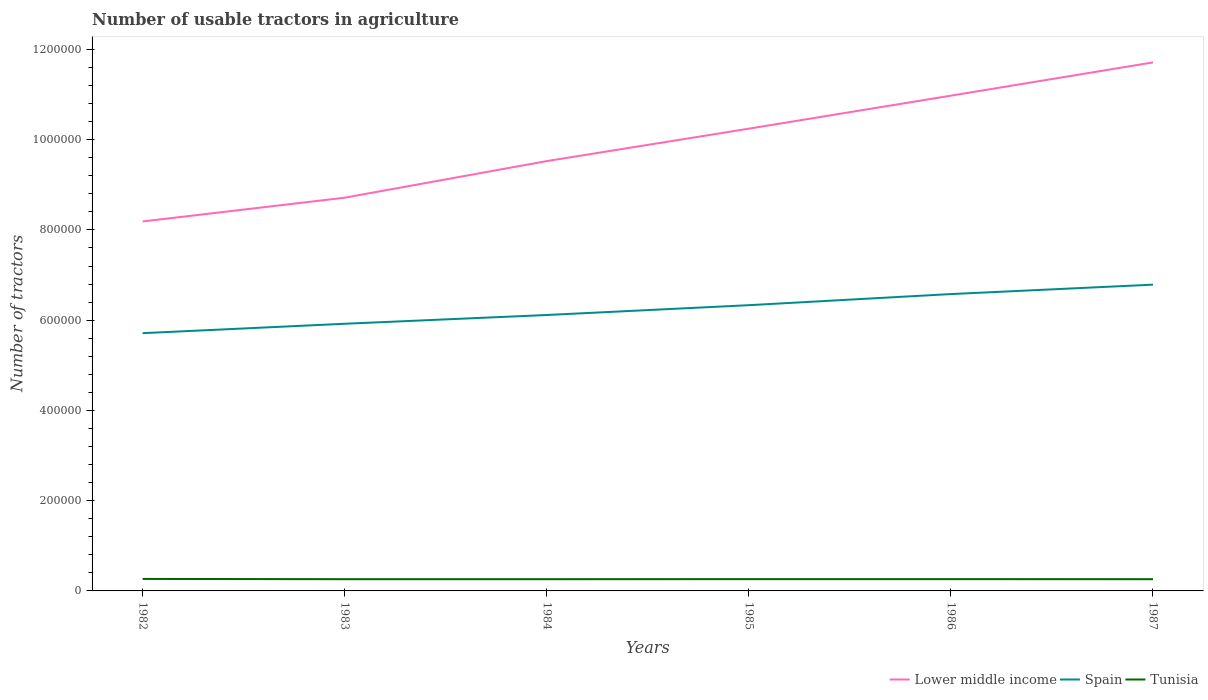Across all years, what is the maximum number of usable tractors in agriculture in Lower middle income?
Give a very brief answer. 8.19e+05. In which year was the number of usable tractors in agriculture in Lower middle income maximum?
Your answer should be very brief. 1982. What is the total number of usable tractors in agriculture in Spain in the graph?
Provide a succinct answer. -2.09e+04. What is the difference between the highest and the second highest number of usable tractors in agriculture in Spain?
Keep it short and to the point. 1.08e+05. What is the difference between the highest and the lowest number of usable tractors in agriculture in Tunisia?
Your response must be concise. 1. Is the number of usable tractors in agriculture in Lower middle income strictly greater than the number of usable tractors in agriculture in Spain over the years?
Keep it short and to the point. No. What is the difference between two consecutive major ticks on the Y-axis?
Ensure brevity in your answer.  2.00e+05. Are the values on the major ticks of Y-axis written in scientific E-notation?
Offer a terse response. No. Does the graph contain any zero values?
Offer a very short reply. No. What is the title of the graph?
Your answer should be compact. Number of usable tractors in agriculture. What is the label or title of the X-axis?
Make the answer very short. Years. What is the label or title of the Y-axis?
Provide a succinct answer. Number of tractors. What is the Number of tractors in Lower middle income in 1982?
Provide a succinct answer. 8.19e+05. What is the Number of tractors of Spain in 1982?
Keep it short and to the point. 5.71e+05. What is the Number of tractors in Tunisia in 1982?
Your answer should be very brief. 2.66e+04. What is the Number of tractors of Lower middle income in 1983?
Offer a terse response. 8.71e+05. What is the Number of tractors in Spain in 1983?
Keep it short and to the point. 5.92e+05. What is the Number of tractors of Tunisia in 1983?
Give a very brief answer. 2.60e+04. What is the Number of tractors in Lower middle income in 1984?
Offer a very short reply. 9.52e+05. What is the Number of tractors of Spain in 1984?
Offer a terse response. 6.11e+05. What is the Number of tractors in Tunisia in 1984?
Your answer should be compact. 2.60e+04. What is the Number of tractors in Lower middle income in 1985?
Provide a succinct answer. 1.02e+06. What is the Number of tractors in Spain in 1985?
Ensure brevity in your answer.  6.33e+05. What is the Number of tractors of Tunisia in 1985?
Provide a short and direct response. 2.61e+04. What is the Number of tractors in Lower middle income in 1986?
Offer a terse response. 1.10e+06. What is the Number of tractors in Spain in 1986?
Keep it short and to the point. 6.58e+05. What is the Number of tractors in Tunisia in 1986?
Offer a terse response. 2.61e+04. What is the Number of tractors in Lower middle income in 1987?
Ensure brevity in your answer.  1.17e+06. What is the Number of tractors in Spain in 1987?
Make the answer very short. 6.79e+05. What is the Number of tractors of Tunisia in 1987?
Provide a short and direct response. 2.60e+04. Across all years, what is the maximum Number of tractors of Lower middle income?
Ensure brevity in your answer.  1.17e+06. Across all years, what is the maximum Number of tractors in Spain?
Your response must be concise. 6.79e+05. Across all years, what is the maximum Number of tractors of Tunisia?
Give a very brief answer. 2.66e+04. Across all years, what is the minimum Number of tractors of Lower middle income?
Your response must be concise. 8.19e+05. Across all years, what is the minimum Number of tractors in Spain?
Provide a succinct answer. 5.71e+05. Across all years, what is the minimum Number of tractors in Tunisia?
Provide a succinct answer. 2.60e+04. What is the total Number of tractors of Lower middle income in the graph?
Your answer should be very brief. 5.94e+06. What is the total Number of tractors of Spain in the graph?
Give a very brief answer. 3.74e+06. What is the total Number of tractors in Tunisia in the graph?
Offer a terse response. 1.57e+05. What is the difference between the Number of tractors in Lower middle income in 1982 and that in 1983?
Your answer should be compact. -5.27e+04. What is the difference between the Number of tractors of Spain in 1982 and that in 1983?
Give a very brief answer. -2.08e+04. What is the difference between the Number of tractors in Tunisia in 1982 and that in 1983?
Provide a short and direct response. 600. What is the difference between the Number of tractors of Lower middle income in 1982 and that in 1984?
Your answer should be compact. -1.34e+05. What is the difference between the Number of tractors of Spain in 1982 and that in 1984?
Ensure brevity in your answer.  -4.03e+04. What is the difference between the Number of tractors in Tunisia in 1982 and that in 1984?
Provide a succinct answer. 600. What is the difference between the Number of tractors in Lower middle income in 1982 and that in 1985?
Your response must be concise. -2.06e+05. What is the difference between the Number of tractors of Spain in 1982 and that in 1985?
Your answer should be compact. -6.20e+04. What is the difference between the Number of tractors in Tunisia in 1982 and that in 1985?
Give a very brief answer. 500. What is the difference between the Number of tractors of Lower middle income in 1982 and that in 1986?
Ensure brevity in your answer.  -2.79e+05. What is the difference between the Number of tractors of Spain in 1982 and that in 1986?
Offer a terse response. -8.67e+04. What is the difference between the Number of tractors of Lower middle income in 1982 and that in 1987?
Keep it short and to the point. -3.52e+05. What is the difference between the Number of tractors of Spain in 1982 and that in 1987?
Ensure brevity in your answer.  -1.08e+05. What is the difference between the Number of tractors in Tunisia in 1982 and that in 1987?
Provide a succinct answer. 600. What is the difference between the Number of tractors in Lower middle income in 1983 and that in 1984?
Ensure brevity in your answer.  -8.11e+04. What is the difference between the Number of tractors of Spain in 1983 and that in 1984?
Your answer should be compact. -1.94e+04. What is the difference between the Number of tractors of Lower middle income in 1983 and that in 1985?
Your answer should be very brief. -1.53e+05. What is the difference between the Number of tractors of Spain in 1983 and that in 1985?
Your answer should be compact. -4.12e+04. What is the difference between the Number of tractors in Tunisia in 1983 and that in 1985?
Provide a short and direct response. -100. What is the difference between the Number of tractors of Lower middle income in 1983 and that in 1986?
Offer a very short reply. -2.26e+05. What is the difference between the Number of tractors of Spain in 1983 and that in 1986?
Your response must be concise. -6.58e+04. What is the difference between the Number of tractors in Tunisia in 1983 and that in 1986?
Offer a very short reply. -100. What is the difference between the Number of tractors in Lower middle income in 1983 and that in 1987?
Make the answer very short. -3.00e+05. What is the difference between the Number of tractors of Spain in 1983 and that in 1987?
Keep it short and to the point. -8.67e+04. What is the difference between the Number of tractors of Lower middle income in 1984 and that in 1985?
Ensure brevity in your answer.  -7.19e+04. What is the difference between the Number of tractors of Spain in 1984 and that in 1985?
Your answer should be compact. -2.18e+04. What is the difference between the Number of tractors of Tunisia in 1984 and that in 1985?
Make the answer very short. -100. What is the difference between the Number of tractors of Lower middle income in 1984 and that in 1986?
Your response must be concise. -1.45e+05. What is the difference between the Number of tractors in Spain in 1984 and that in 1986?
Keep it short and to the point. -4.64e+04. What is the difference between the Number of tractors of Tunisia in 1984 and that in 1986?
Your response must be concise. -100. What is the difference between the Number of tractors of Lower middle income in 1984 and that in 1987?
Offer a very short reply. -2.19e+05. What is the difference between the Number of tractors of Spain in 1984 and that in 1987?
Keep it short and to the point. -6.72e+04. What is the difference between the Number of tractors of Tunisia in 1984 and that in 1987?
Provide a succinct answer. 0. What is the difference between the Number of tractors in Lower middle income in 1985 and that in 1986?
Keep it short and to the point. -7.31e+04. What is the difference between the Number of tractors in Spain in 1985 and that in 1986?
Keep it short and to the point. -2.46e+04. What is the difference between the Number of tractors of Tunisia in 1985 and that in 1986?
Provide a succinct answer. 0. What is the difference between the Number of tractors of Lower middle income in 1985 and that in 1987?
Keep it short and to the point. -1.47e+05. What is the difference between the Number of tractors in Spain in 1985 and that in 1987?
Provide a short and direct response. -4.55e+04. What is the difference between the Number of tractors of Tunisia in 1985 and that in 1987?
Your answer should be compact. 100. What is the difference between the Number of tractors in Lower middle income in 1986 and that in 1987?
Your answer should be very brief. -7.37e+04. What is the difference between the Number of tractors in Spain in 1986 and that in 1987?
Offer a terse response. -2.09e+04. What is the difference between the Number of tractors of Lower middle income in 1982 and the Number of tractors of Spain in 1983?
Your response must be concise. 2.27e+05. What is the difference between the Number of tractors in Lower middle income in 1982 and the Number of tractors in Tunisia in 1983?
Your answer should be compact. 7.93e+05. What is the difference between the Number of tractors of Spain in 1982 and the Number of tractors of Tunisia in 1983?
Keep it short and to the point. 5.45e+05. What is the difference between the Number of tractors in Lower middle income in 1982 and the Number of tractors in Spain in 1984?
Your response must be concise. 2.07e+05. What is the difference between the Number of tractors of Lower middle income in 1982 and the Number of tractors of Tunisia in 1984?
Provide a short and direct response. 7.93e+05. What is the difference between the Number of tractors in Spain in 1982 and the Number of tractors in Tunisia in 1984?
Offer a terse response. 5.45e+05. What is the difference between the Number of tractors in Lower middle income in 1982 and the Number of tractors in Spain in 1985?
Offer a terse response. 1.86e+05. What is the difference between the Number of tractors of Lower middle income in 1982 and the Number of tractors of Tunisia in 1985?
Provide a short and direct response. 7.93e+05. What is the difference between the Number of tractors of Spain in 1982 and the Number of tractors of Tunisia in 1985?
Offer a very short reply. 5.45e+05. What is the difference between the Number of tractors in Lower middle income in 1982 and the Number of tractors in Spain in 1986?
Keep it short and to the point. 1.61e+05. What is the difference between the Number of tractors of Lower middle income in 1982 and the Number of tractors of Tunisia in 1986?
Your answer should be compact. 7.93e+05. What is the difference between the Number of tractors of Spain in 1982 and the Number of tractors of Tunisia in 1986?
Your answer should be compact. 5.45e+05. What is the difference between the Number of tractors of Lower middle income in 1982 and the Number of tractors of Spain in 1987?
Provide a short and direct response. 1.40e+05. What is the difference between the Number of tractors of Lower middle income in 1982 and the Number of tractors of Tunisia in 1987?
Your answer should be compact. 7.93e+05. What is the difference between the Number of tractors in Spain in 1982 and the Number of tractors in Tunisia in 1987?
Keep it short and to the point. 5.45e+05. What is the difference between the Number of tractors in Lower middle income in 1983 and the Number of tractors in Spain in 1984?
Offer a terse response. 2.60e+05. What is the difference between the Number of tractors in Lower middle income in 1983 and the Number of tractors in Tunisia in 1984?
Offer a terse response. 8.45e+05. What is the difference between the Number of tractors of Spain in 1983 and the Number of tractors of Tunisia in 1984?
Offer a very short reply. 5.66e+05. What is the difference between the Number of tractors of Lower middle income in 1983 and the Number of tractors of Spain in 1985?
Your answer should be compact. 2.38e+05. What is the difference between the Number of tractors of Lower middle income in 1983 and the Number of tractors of Tunisia in 1985?
Ensure brevity in your answer.  8.45e+05. What is the difference between the Number of tractors in Spain in 1983 and the Number of tractors in Tunisia in 1985?
Your answer should be compact. 5.66e+05. What is the difference between the Number of tractors in Lower middle income in 1983 and the Number of tractors in Spain in 1986?
Offer a terse response. 2.14e+05. What is the difference between the Number of tractors of Lower middle income in 1983 and the Number of tractors of Tunisia in 1986?
Provide a succinct answer. 8.45e+05. What is the difference between the Number of tractors of Spain in 1983 and the Number of tractors of Tunisia in 1986?
Keep it short and to the point. 5.66e+05. What is the difference between the Number of tractors of Lower middle income in 1983 and the Number of tractors of Spain in 1987?
Offer a very short reply. 1.93e+05. What is the difference between the Number of tractors of Lower middle income in 1983 and the Number of tractors of Tunisia in 1987?
Provide a succinct answer. 8.45e+05. What is the difference between the Number of tractors of Spain in 1983 and the Number of tractors of Tunisia in 1987?
Give a very brief answer. 5.66e+05. What is the difference between the Number of tractors in Lower middle income in 1984 and the Number of tractors in Spain in 1985?
Make the answer very short. 3.19e+05. What is the difference between the Number of tractors in Lower middle income in 1984 and the Number of tractors in Tunisia in 1985?
Keep it short and to the point. 9.26e+05. What is the difference between the Number of tractors of Spain in 1984 and the Number of tractors of Tunisia in 1985?
Your answer should be compact. 5.85e+05. What is the difference between the Number of tractors of Lower middle income in 1984 and the Number of tractors of Spain in 1986?
Offer a terse response. 2.95e+05. What is the difference between the Number of tractors of Lower middle income in 1984 and the Number of tractors of Tunisia in 1986?
Make the answer very short. 9.26e+05. What is the difference between the Number of tractors in Spain in 1984 and the Number of tractors in Tunisia in 1986?
Offer a terse response. 5.85e+05. What is the difference between the Number of tractors of Lower middle income in 1984 and the Number of tractors of Spain in 1987?
Offer a very short reply. 2.74e+05. What is the difference between the Number of tractors in Lower middle income in 1984 and the Number of tractors in Tunisia in 1987?
Provide a succinct answer. 9.26e+05. What is the difference between the Number of tractors of Spain in 1984 and the Number of tractors of Tunisia in 1987?
Give a very brief answer. 5.85e+05. What is the difference between the Number of tractors in Lower middle income in 1985 and the Number of tractors in Spain in 1986?
Offer a terse response. 3.67e+05. What is the difference between the Number of tractors in Lower middle income in 1985 and the Number of tractors in Tunisia in 1986?
Ensure brevity in your answer.  9.98e+05. What is the difference between the Number of tractors of Spain in 1985 and the Number of tractors of Tunisia in 1986?
Make the answer very short. 6.07e+05. What is the difference between the Number of tractors of Lower middle income in 1985 and the Number of tractors of Spain in 1987?
Provide a short and direct response. 3.46e+05. What is the difference between the Number of tractors in Lower middle income in 1985 and the Number of tractors in Tunisia in 1987?
Provide a short and direct response. 9.98e+05. What is the difference between the Number of tractors of Spain in 1985 and the Number of tractors of Tunisia in 1987?
Offer a terse response. 6.07e+05. What is the difference between the Number of tractors of Lower middle income in 1986 and the Number of tractors of Spain in 1987?
Your answer should be compact. 4.19e+05. What is the difference between the Number of tractors of Lower middle income in 1986 and the Number of tractors of Tunisia in 1987?
Give a very brief answer. 1.07e+06. What is the difference between the Number of tractors in Spain in 1986 and the Number of tractors in Tunisia in 1987?
Your response must be concise. 6.32e+05. What is the average Number of tractors in Lower middle income per year?
Your answer should be compact. 9.89e+05. What is the average Number of tractors in Spain per year?
Offer a very short reply. 6.24e+05. What is the average Number of tractors of Tunisia per year?
Offer a very short reply. 2.61e+04. In the year 1982, what is the difference between the Number of tractors of Lower middle income and Number of tractors of Spain?
Provide a short and direct response. 2.48e+05. In the year 1982, what is the difference between the Number of tractors of Lower middle income and Number of tractors of Tunisia?
Ensure brevity in your answer.  7.92e+05. In the year 1982, what is the difference between the Number of tractors of Spain and Number of tractors of Tunisia?
Provide a short and direct response. 5.45e+05. In the year 1983, what is the difference between the Number of tractors of Lower middle income and Number of tractors of Spain?
Offer a terse response. 2.79e+05. In the year 1983, what is the difference between the Number of tractors of Lower middle income and Number of tractors of Tunisia?
Offer a very short reply. 8.45e+05. In the year 1983, what is the difference between the Number of tractors in Spain and Number of tractors in Tunisia?
Your answer should be compact. 5.66e+05. In the year 1984, what is the difference between the Number of tractors in Lower middle income and Number of tractors in Spain?
Provide a short and direct response. 3.41e+05. In the year 1984, what is the difference between the Number of tractors of Lower middle income and Number of tractors of Tunisia?
Ensure brevity in your answer.  9.26e+05. In the year 1984, what is the difference between the Number of tractors in Spain and Number of tractors in Tunisia?
Make the answer very short. 5.85e+05. In the year 1985, what is the difference between the Number of tractors in Lower middle income and Number of tractors in Spain?
Your answer should be compact. 3.91e+05. In the year 1985, what is the difference between the Number of tractors of Lower middle income and Number of tractors of Tunisia?
Make the answer very short. 9.98e+05. In the year 1985, what is the difference between the Number of tractors in Spain and Number of tractors in Tunisia?
Provide a short and direct response. 6.07e+05. In the year 1986, what is the difference between the Number of tractors in Lower middle income and Number of tractors in Spain?
Make the answer very short. 4.40e+05. In the year 1986, what is the difference between the Number of tractors in Lower middle income and Number of tractors in Tunisia?
Keep it short and to the point. 1.07e+06. In the year 1986, what is the difference between the Number of tractors in Spain and Number of tractors in Tunisia?
Make the answer very short. 6.32e+05. In the year 1987, what is the difference between the Number of tractors in Lower middle income and Number of tractors in Spain?
Keep it short and to the point. 4.93e+05. In the year 1987, what is the difference between the Number of tractors in Lower middle income and Number of tractors in Tunisia?
Offer a very short reply. 1.15e+06. In the year 1987, what is the difference between the Number of tractors in Spain and Number of tractors in Tunisia?
Ensure brevity in your answer.  6.53e+05. What is the ratio of the Number of tractors in Lower middle income in 1982 to that in 1983?
Ensure brevity in your answer.  0.94. What is the ratio of the Number of tractors in Spain in 1982 to that in 1983?
Give a very brief answer. 0.96. What is the ratio of the Number of tractors of Tunisia in 1982 to that in 1983?
Offer a terse response. 1.02. What is the ratio of the Number of tractors in Lower middle income in 1982 to that in 1984?
Provide a succinct answer. 0.86. What is the ratio of the Number of tractors in Spain in 1982 to that in 1984?
Offer a very short reply. 0.93. What is the ratio of the Number of tractors in Tunisia in 1982 to that in 1984?
Give a very brief answer. 1.02. What is the ratio of the Number of tractors of Lower middle income in 1982 to that in 1985?
Your answer should be compact. 0.8. What is the ratio of the Number of tractors in Spain in 1982 to that in 1985?
Ensure brevity in your answer.  0.9. What is the ratio of the Number of tractors of Tunisia in 1982 to that in 1985?
Make the answer very short. 1.02. What is the ratio of the Number of tractors of Lower middle income in 1982 to that in 1986?
Provide a short and direct response. 0.75. What is the ratio of the Number of tractors of Spain in 1982 to that in 1986?
Provide a short and direct response. 0.87. What is the ratio of the Number of tractors in Tunisia in 1982 to that in 1986?
Keep it short and to the point. 1.02. What is the ratio of the Number of tractors of Lower middle income in 1982 to that in 1987?
Offer a terse response. 0.7. What is the ratio of the Number of tractors of Spain in 1982 to that in 1987?
Offer a very short reply. 0.84. What is the ratio of the Number of tractors in Tunisia in 1982 to that in 1987?
Ensure brevity in your answer.  1.02. What is the ratio of the Number of tractors of Lower middle income in 1983 to that in 1984?
Offer a terse response. 0.91. What is the ratio of the Number of tractors in Spain in 1983 to that in 1984?
Make the answer very short. 0.97. What is the ratio of the Number of tractors of Lower middle income in 1983 to that in 1985?
Provide a short and direct response. 0.85. What is the ratio of the Number of tractors of Spain in 1983 to that in 1985?
Your answer should be compact. 0.93. What is the ratio of the Number of tractors in Tunisia in 1983 to that in 1985?
Give a very brief answer. 1. What is the ratio of the Number of tractors in Lower middle income in 1983 to that in 1986?
Offer a terse response. 0.79. What is the ratio of the Number of tractors of Spain in 1983 to that in 1986?
Your answer should be very brief. 0.9. What is the ratio of the Number of tractors of Lower middle income in 1983 to that in 1987?
Give a very brief answer. 0.74. What is the ratio of the Number of tractors of Spain in 1983 to that in 1987?
Your response must be concise. 0.87. What is the ratio of the Number of tractors of Tunisia in 1983 to that in 1987?
Your answer should be compact. 1. What is the ratio of the Number of tractors of Lower middle income in 1984 to that in 1985?
Offer a very short reply. 0.93. What is the ratio of the Number of tractors of Spain in 1984 to that in 1985?
Provide a succinct answer. 0.97. What is the ratio of the Number of tractors of Tunisia in 1984 to that in 1985?
Make the answer very short. 1. What is the ratio of the Number of tractors of Lower middle income in 1984 to that in 1986?
Give a very brief answer. 0.87. What is the ratio of the Number of tractors in Spain in 1984 to that in 1986?
Ensure brevity in your answer.  0.93. What is the ratio of the Number of tractors of Lower middle income in 1984 to that in 1987?
Provide a short and direct response. 0.81. What is the ratio of the Number of tractors in Spain in 1984 to that in 1987?
Your answer should be compact. 0.9. What is the ratio of the Number of tractors in Lower middle income in 1985 to that in 1986?
Provide a short and direct response. 0.93. What is the ratio of the Number of tractors of Spain in 1985 to that in 1986?
Offer a very short reply. 0.96. What is the ratio of the Number of tractors in Lower middle income in 1985 to that in 1987?
Provide a short and direct response. 0.87. What is the ratio of the Number of tractors of Spain in 1985 to that in 1987?
Offer a terse response. 0.93. What is the ratio of the Number of tractors of Lower middle income in 1986 to that in 1987?
Your response must be concise. 0.94. What is the ratio of the Number of tractors in Spain in 1986 to that in 1987?
Make the answer very short. 0.97. What is the ratio of the Number of tractors in Tunisia in 1986 to that in 1987?
Ensure brevity in your answer.  1. What is the difference between the highest and the second highest Number of tractors of Lower middle income?
Ensure brevity in your answer.  7.37e+04. What is the difference between the highest and the second highest Number of tractors in Spain?
Offer a terse response. 2.09e+04. What is the difference between the highest and the second highest Number of tractors in Tunisia?
Your response must be concise. 500. What is the difference between the highest and the lowest Number of tractors of Lower middle income?
Give a very brief answer. 3.52e+05. What is the difference between the highest and the lowest Number of tractors in Spain?
Ensure brevity in your answer.  1.08e+05. What is the difference between the highest and the lowest Number of tractors of Tunisia?
Provide a succinct answer. 600. 